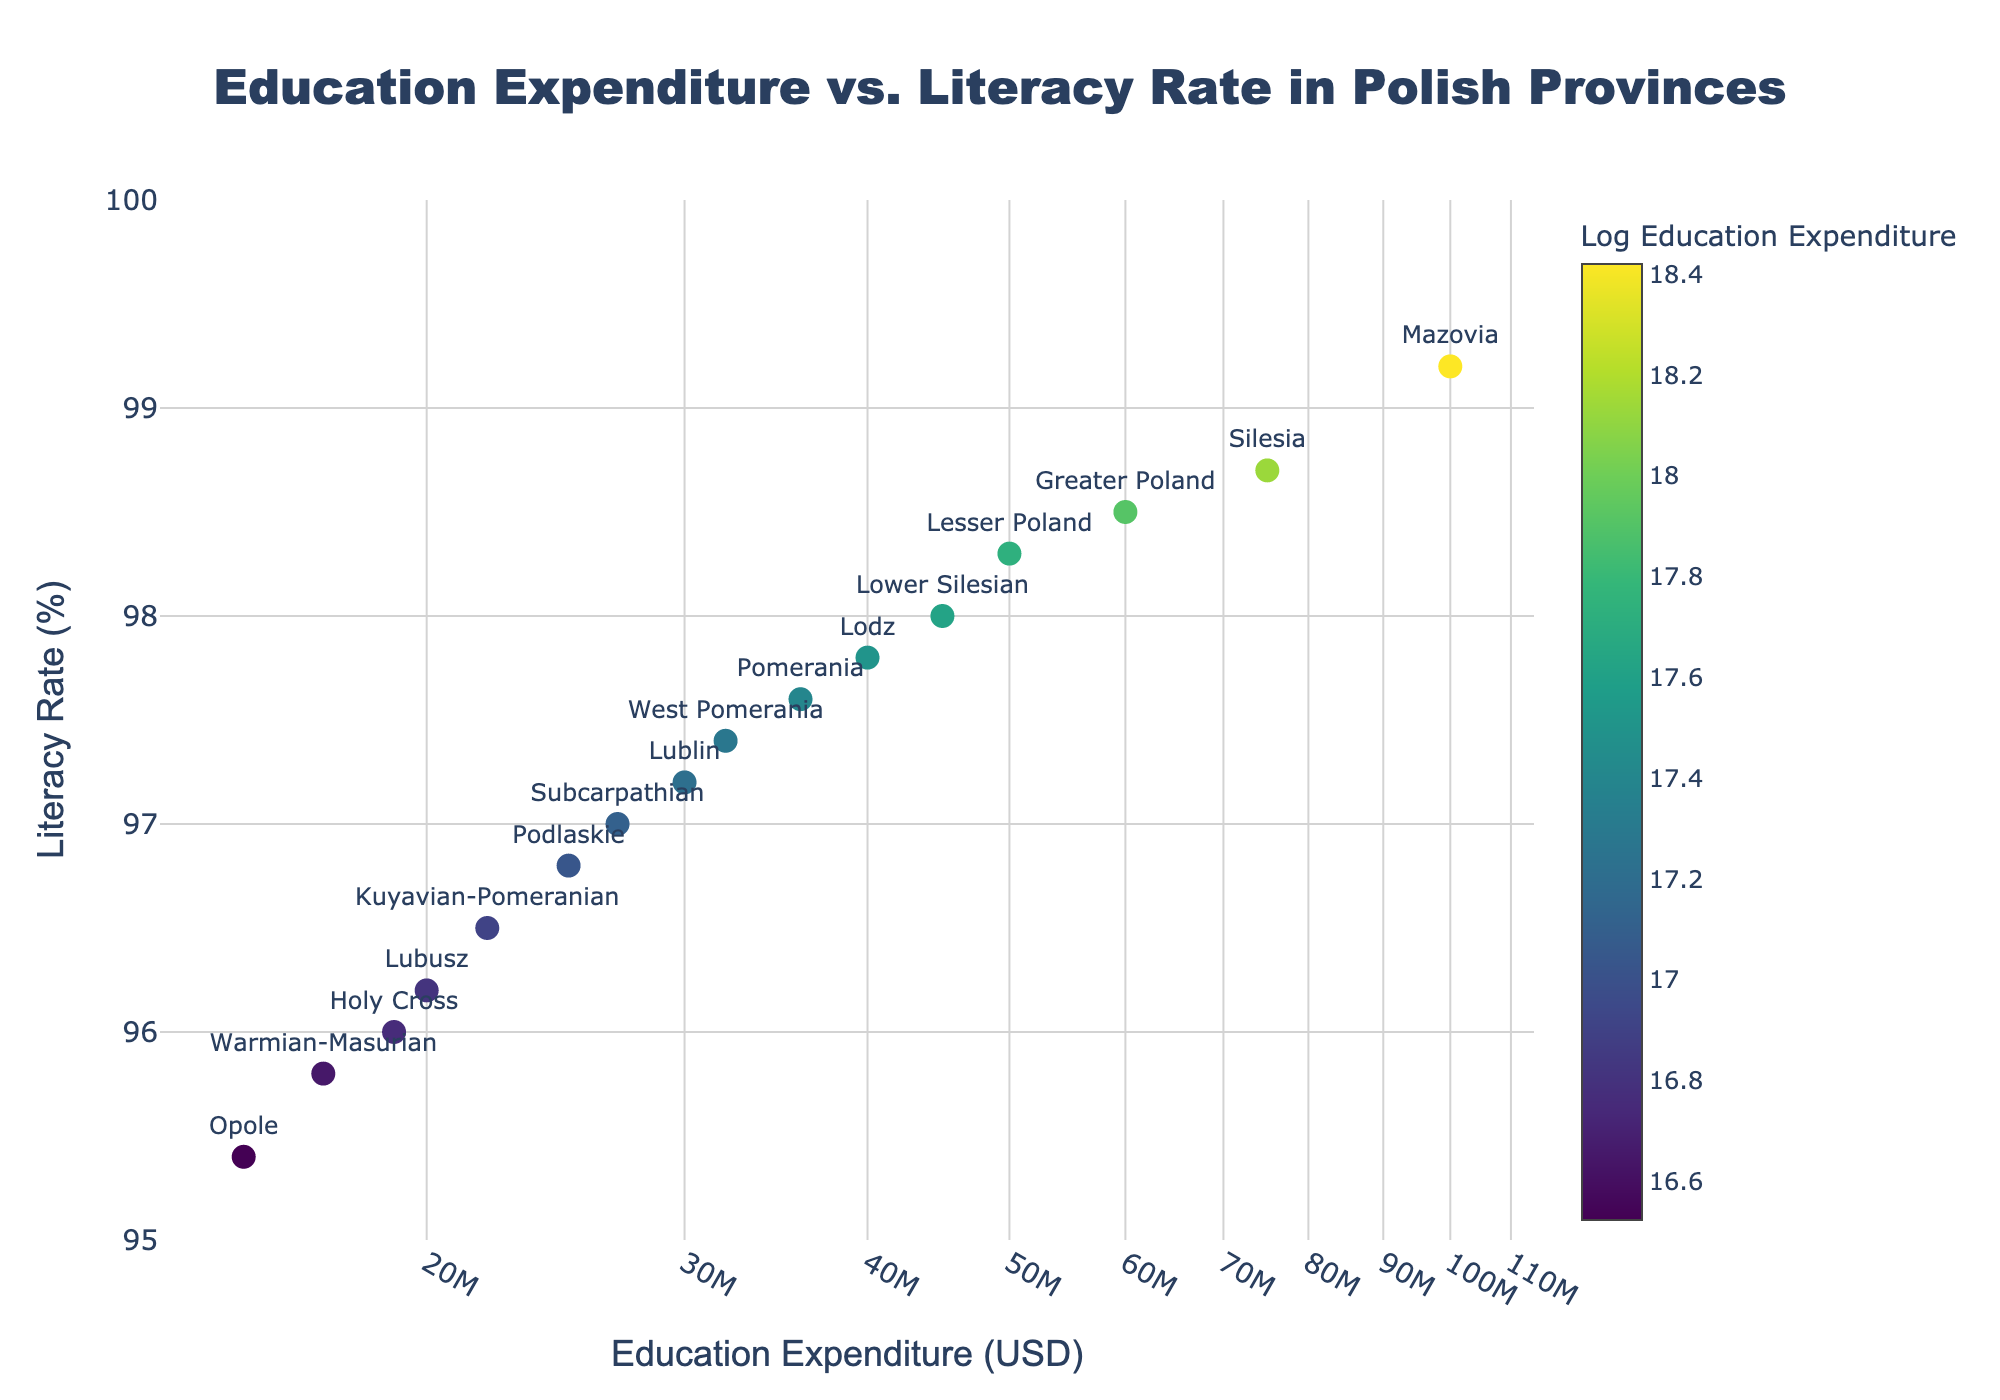What is the title of the scatter plot? The title of the scatter plot is displayed at the top center of the figure. It is written in a larger and bold font to make it stand out.
Answer: Education Expenditure vs. Literacy Rate in Polish Provinces How many provinces are included in the scatter plot? Each province is represented by a marker on the scatter plot, and each marker is labeled with the name of the province. Counting the labels will give the total number of provinces.
Answer: 16 What is the range of the literacy rate on the y-axis? The y-axis title and ticks provide information about the range of the literacy rate. Observing the minimum and maximum values on the y-axis gives the range.
Answer: 95% to 100% Which province has the highest education expenditure? The x-axis represents education expenditure, and each marker's position along this axis indicates the expenditure for that province. The rightmost marker corresponds to the highest expenditure.
Answer: Mazovia Is there a province with a literacy rate of exactly 98.0%? Looking at the y-axis and locating the position of a marker at 98.0% will show if any province has this exact literacy rate.
Answer: Yes, Lower Silesian Which provinces have a literacy rate lower than 97.0%? Identify markers below the 97.0% mark on the y-axis and read the label for each corresponding province.
Answer: Podlaskie, Kuyavian-Pomeranian, Lubusz, Holy Cross, Warmian-Masurian, Opole What is the color scale title that indicates the log of education expenditure? The color bar next to the scatter plot shows the title for the color scale, indicating it represents the log-transformed education expenditure.
Answer: Log Education Expenditure What trend can be observed between education expenditure and literacy rate? Generally, by observing the scatter plot distribution, an upward or downward trend between the variables can be assessed.
Answer: Generally positive trend Which provinces have the closest education expenditure and literacy rate? Look for markers that are clustered closely together both horizontally and vertically and note the names of those provinces.
Answer: Lubusz and Kuyavian-Pomeranian How does the literacy rate of Mazovia compare to other provinces? Check Mazovia's marker on the scatter plot and compare its vertical position (literacy rate) with other markers.
Answer: Mazovia has one of the highest literacy rates 